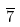<formula> <loc_0><loc_0><loc_500><loc_500>\overline { 7 }</formula> 